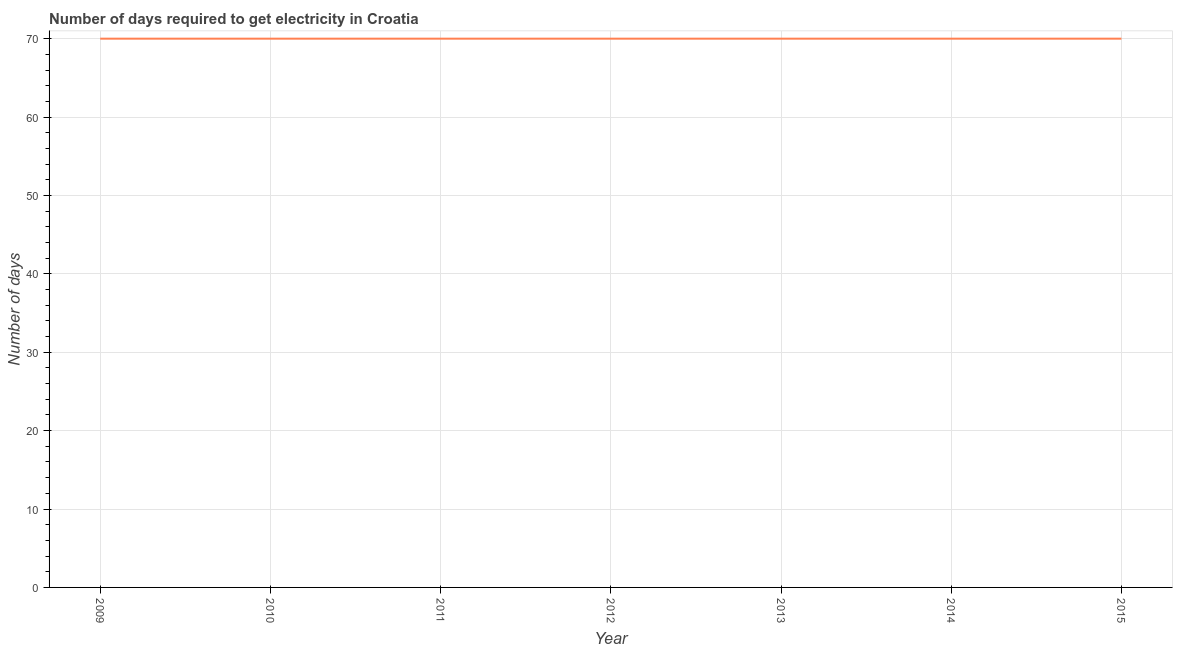What is the time to get electricity in 2010?
Your response must be concise. 70. Across all years, what is the maximum time to get electricity?
Your answer should be very brief. 70. Across all years, what is the minimum time to get electricity?
Your answer should be very brief. 70. In which year was the time to get electricity maximum?
Offer a terse response. 2009. In which year was the time to get electricity minimum?
Give a very brief answer. 2009. What is the sum of the time to get electricity?
Offer a very short reply. 490. What is the difference between the time to get electricity in 2013 and 2015?
Provide a succinct answer. 0. What is the ratio of the time to get electricity in 2010 to that in 2013?
Provide a succinct answer. 1. Is the time to get electricity in 2009 less than that in 2015?
Ensure brevity in your answer.  No. Is the difference between the time to get electricity in 2014 and 2015 greater than the difference between any two years?
Offer a very short reply. Yes. What is the difference between the highest and the second highest time to get electricity?
Make the answer very short. 0. What is the difference between the highest and the lowest time to get electricity?
Your answer should be very brief. 0. In how many years, is the time to get electricity greater than the average time to get electricity taken over all years?
Your answer should be very brief. 0. What is the difference between two consecutive major ticks on the Y-axis?
Make the answer very short. 10. Are the values on the major ticks of Y-axis written in scientific E-notation?
Keep it short and to the point. No. Does the graph contain grids?
Keep it short and to the point. Yes. What is the title of the graph?
Your answer should be very brief. Number of days required to get electricity in Croatia. What is the label or title of the Y-axis?
Offer a very short reply. Number of days. What is the Number of days of 2013?
Provide a succinct answer. 70. What is the Number of days of 2014?
Your answer should be very brief. 70. What is the difference between the Number of days in 2009 and 2010?
Offer a very short reply. 0. What is the difference between the Number of days in 2009 and 2012?
Your answer should be compact. 0. What is the difference between the Number of days in 2009 and 2014?
Your response must be concise. 0. What is the difference between the Number of days in 2009 and 2015?
Offer a very short reply. 0. What is the difference between the Number of days in 2010 and 2011?
Give a very brief answer. 0. What is the difference between the Number of days in 2010 and 2012?
Make the answer very short. 0. What is the difference between the Number of days in 2011 and 2012?
Give a very brief answer. 0. What is the difference between the Number of days in 2011 and 2013?
Provide a short and direct response. 0. What is the difference between the Number of days in 2011 and 2014?
Give a very brief answer. 0. What is the difference between the Number of days in 2011 and 2015?
Offer a terse response. 0. What is the difference between the Number of days in 2012 and 2014?
Keep it short and to the point. 0. What is the difference between the Number of days in 2013 and 2015?
Ensure brevity in your answer.  0. What is the ratio of the Number of days in 2009 to that in 2014?
Provide a succinct answer. 1. What is the ratio of the Number of days in 2010 to that in 2012?
Provide a succinct answer. 1. What is the ratio of the Number of days in 2010 to that in 2013?
Keep it short and to the point. 1. What is the ratio of the Number of days in 2011 to that in 2012?
Offer a very short reply. 1. What is the ratio of the Number of days in 2011 to that in 2014?
Offer a terse response. 1. What is the ratio of the Number of days in 2011 to that in 2015?
Offer a very short reply. 1. What is the ratio of the Number of days in 2012 to that in 2015?
Make the answer very short. 1. What is the ratio of the Number of days in 2013 to that in 2015?
Ensure brevity in your answer.  1. What is the ratio of the Number of days in 2014 to that in 2015?
Your answer should be compact. 1. 